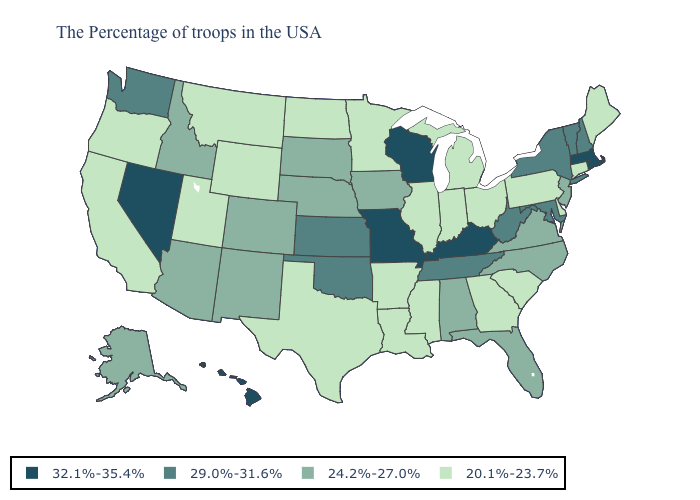What is the value of Tennessee?
Short answer required. 29.0%-31.6%. Among the states that border Wisconsin , which have the highest value?
Short answer required. Iowa. Name the states that have a value in the range 20.1%-23.7%?
Be succinct. Maine, Connecticut, Delaware, Pennsylvania, South Carolina, Ohio, Georgia, Michigan, Indiana, Illinois, Mississippi, Louisiana, Arkansas, Minnesota, Texas, North Dakota, Wyoming, Utah, Montana, California, Oregon. Name the states that have a value in the range 29.0%-31.6%?
Answer briefly. New Hampshire, Vermont, New York, Maryland, West Virginia, Tennessee, Kansas, Oklahoma, Washington. Name the states that have a value in the range 29.0%-31.6%?
Write a very short answer. New Hampshire, Vermont, New York, Maryland, West Virginia, Tennessee, Kansas, Oklahoma, Washington. Which states have the lowest value in the USA?
Write a very short answer. Maine, Connecticut, Delaware, Pennsylvania, South Carolina, Ohio, Georgia, Michigan, Indiana, Illinois, Mississippi, Louisiana, Arkansas, Minnesota, Texas, North Dakota, Wyoming, Utah, Montana, California, Oregon. What is the lowest value in states that border Indiana?
Quick response, please. 20.1%-23.7%. Name the states that have a value in the range 29.0%-31.6%?
Write a very short answer. New Hampshire, Vermont, New York, Maryland, West Virginia, Tennessee, Kansas, Oklahoma, Washington. Name the states that have a value in the range 32.1%-35.4%?
Be succinct. Massachusetts, Rhode Island, Kentucky, Wisconsin, Missouri, Nevada, Hawaii. Does Hawaii have the highest value in the West?
Quick response, please. Yes. Name the states that have a value in the range 29.0%-31.6%?
Quick response, please. New Hampshire, Vermont, New York, Maryland, West Virginia, Tennessee, Kansas, Oklahoma, Washington. What is the highest value in the South ?
Give a very brief answer. 32.1%-35.4%. Does Wisconsin have the highest value in the USA?
Write a very short answer. Yes. Among the states that border Ohio , which have the lowest value?
Concise answer only. Pennsylvania, Michigan, Indiana. 